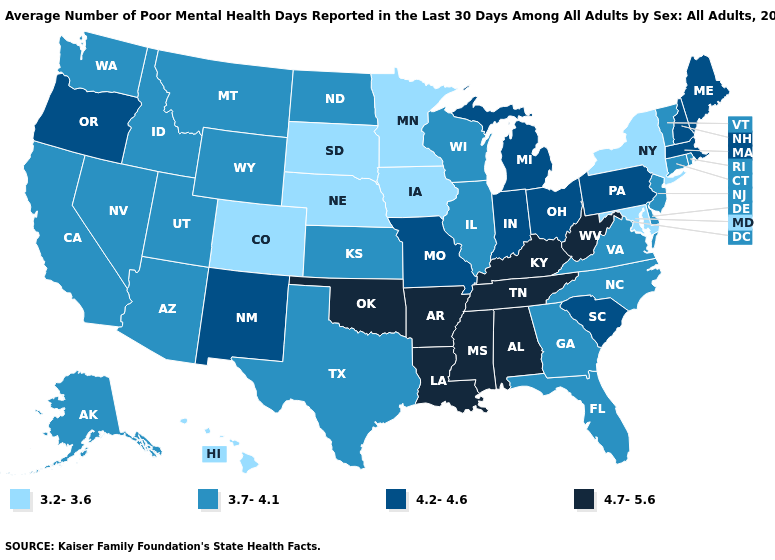What is the lowest value in the West?
Short answer required. 3.2-3.6. Does Pennsylvania have the lowest value in the Northeast?
Be succinct. No. Does the first symbol in the legend represent the smallest category?
Quick response, please. Yes. What is the value of Florida?
Short answer required. 3.7-4.1. Among the states that border Florida , does Alabama have the lowest value?
Write a very short answer. No. What is the value of Alaska?
Keep it brief. 3.7-4.1. Among the states that border Florida , which have the lowest value?
Give a very brief answer. Georgia. Does Utah have the lowest value in the USA?
Answer briefly. No. What is the value of North Carolina?
Quick response, please. 3.7-4.1. Name the states that have a value in the range 3.7-4.1?
Concise answer only. Alaska, Arizona, California, Connecticut, Delaware, Florida, Georgia, Idaho, Illinois, Kansas, Montana, Nevada, New Jersey, North Carolina, North Dakota, Rhode Island, Texas, Utah, Vermont, Virginia, Washington, Wisconsin, Wyoming. Does West Virginia have the highest value in the USA?
Quick response, please. Yes. Does Missouri have the lowest value in the MidWest?
Give a very brief answer. No. Name the states that have a value in the range 4.2-4.6?
Short answer required. Indiana, Maine, Massachusetts, Michigan, Missouri, New Hampshire, New Mexico, Ohio, Oregon, Pennsylvania, South Carolina. Which states have the lowest value in the USA?
Be succinct. Colorado, Hawaii, Iowa, Maryland, Minnesota, Nebraska, New York, South Dakota. Name the states that have a value in the range 3.7-4.1?
Short answer required. Alaska, Arizona, California, Connecticut, Delaware, Florida, Georgia, Idaho, Illinois, Kansas, Montana, Nevada, New Jersey, North Carolina, North Dakota, Rhode Island, Texas, Utah, Vermont, Virginia, Washington, Wisconsin, Wyoming. 